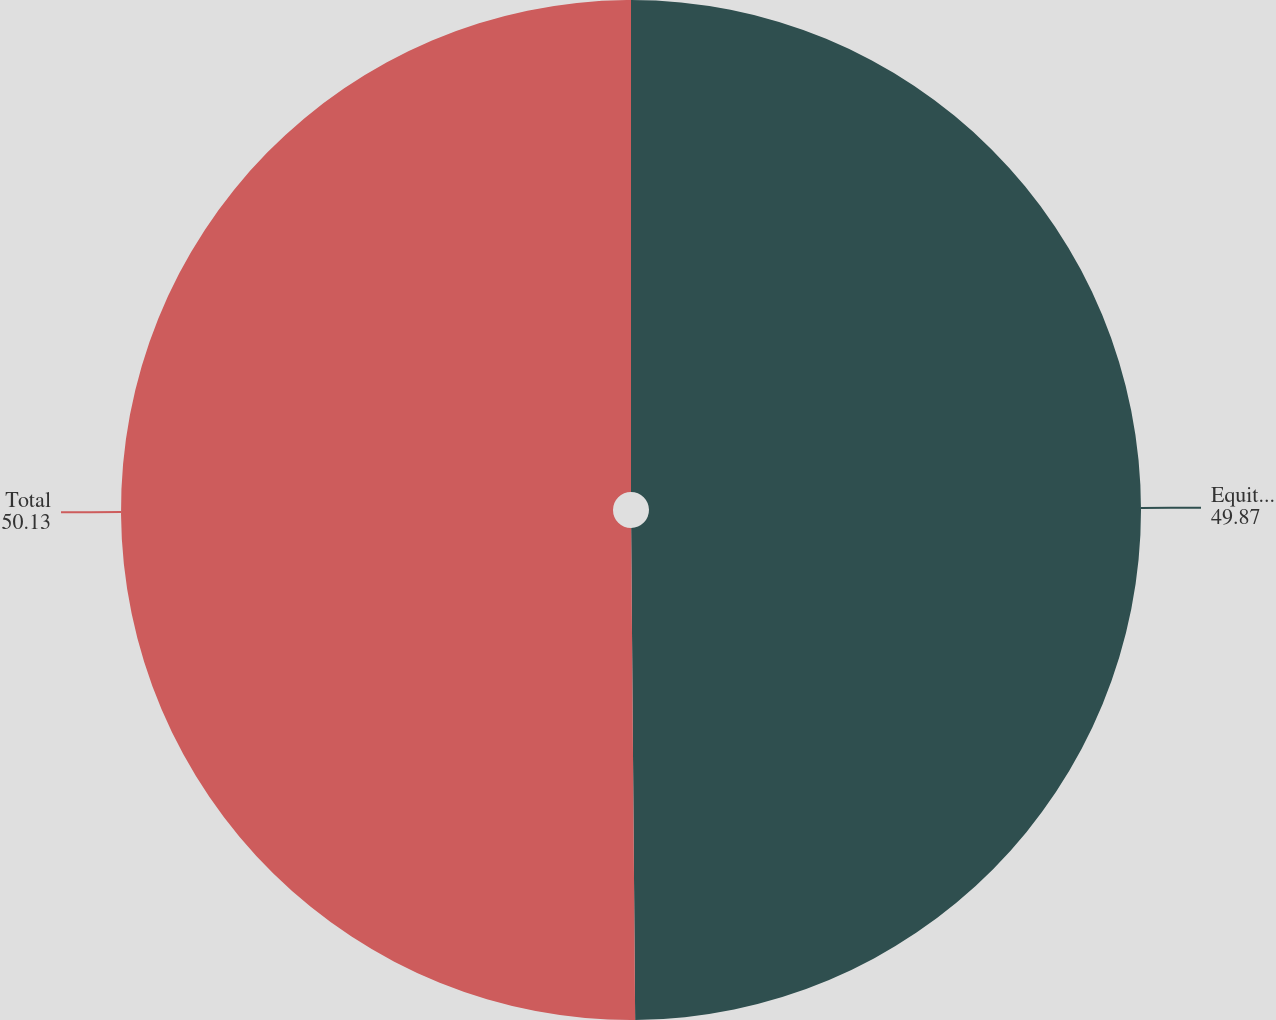Convert chart. <chart><loc_0><loc_0><loc_500><loc_500><pie_chart><fcel>Equity compensation plans<fcel>Total<nl><fcel>49.87%<fcel>50.13%<nl></chart> 